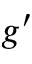Convert formula to latex. <formula><loc_0><loc_0><loc_500><loc_500>g ^ { \prime }</formula> 